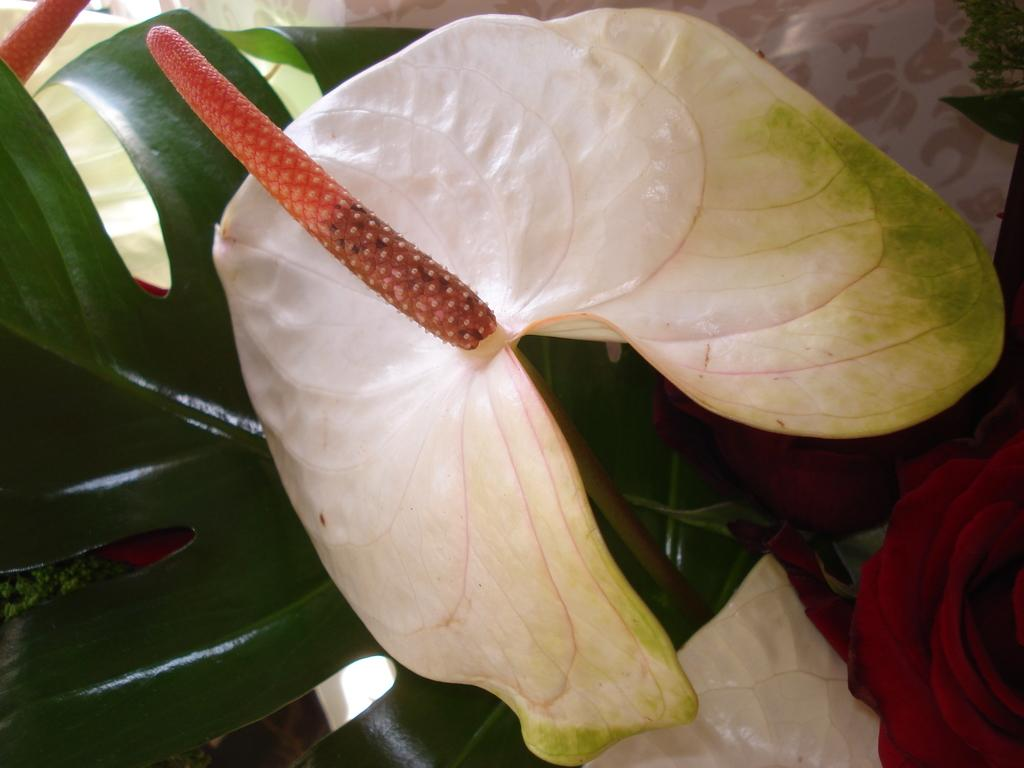What type of living organism can be seen in the image? There is a plant in the image. What type of fruit is visible in the image? There is a white-colored fruit in the image. Can you describe the orange object inside the fruit? There is something in orange color present in the middle of the fruit. How many ducks are flying over the plant in the image? There are no ducks present in the image. What type of legal advice is being given in the image? There is no lawyer or legal advice present in the image. 